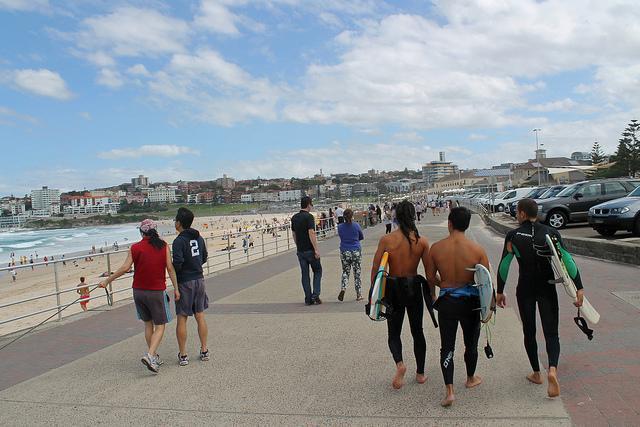How many surfers are walking on the sidewalk?
Give a very brief answer. 3. How many people are not wearing shirts?
Give a very brief answer. 2. How many people are there?
Give a very brief answer. 7. How many bears are in the image?
Give a very brief answer. 0. 